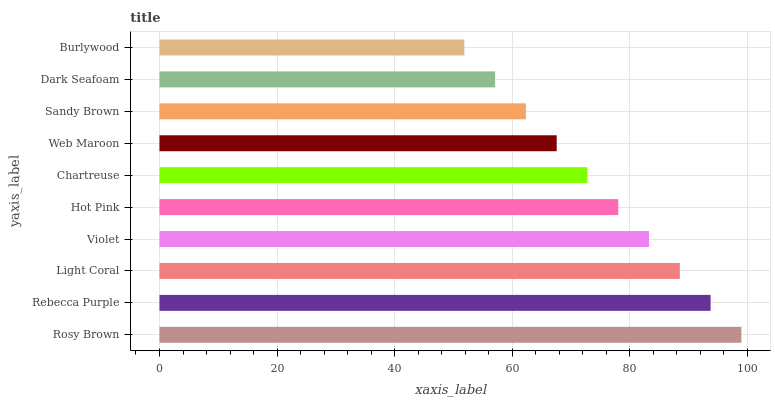Is Burlywood the minimum?
Answer yes or no. Yes. Is Rosy Brown the maximum?
Answer yes or no. Yes. Is Rebecca Purple the minimum?
Answer yes or no. No. Is Rebecca Purple the maximum?
Answer yes or no. No. Is Rosy Brown greater than Rebecca Purple?
Answer yes or no. Yes. Is Rebecca Purple less than Rosy Brown?
Answer yes or no. Yes. Is Rebecca Purple greater than Rosy Brown?
Answer yes or no. No. Is Rosy Brown less than Rebecca Purple?
Answer yes or no. No. Is Hot Pink the high median?
Answer yes or no. Yes. Is Chartreuse the low median?
Answer yes or no. Yes. Is Rebecca Purple the high median?
Answer yes or no. No. Is Rebecca Purple the low median?
Answer yes or no. No. 